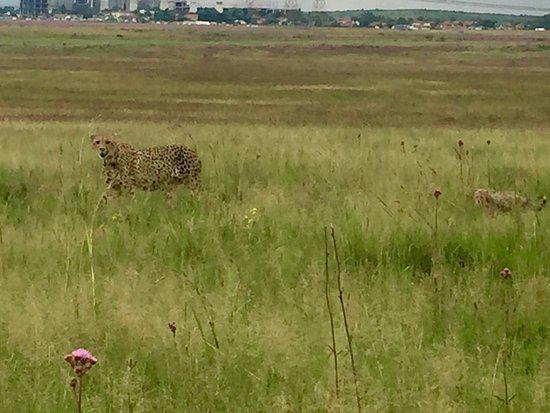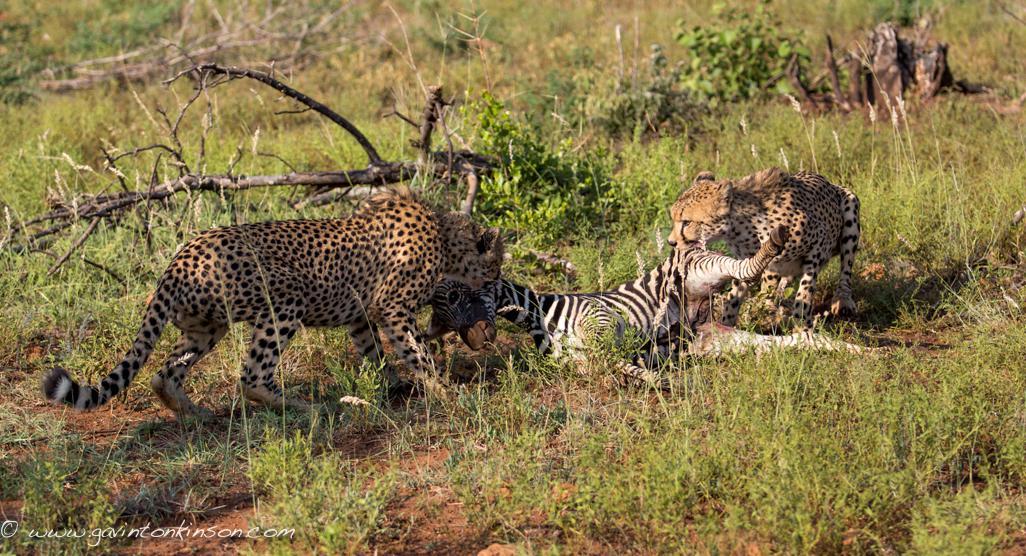The first image is the image on the left, the second image is the image on the right. Analyze the images presented: Is the assertion "The right image contains a single cheetah." valid? Answer yes or no. No. The first image is the image on the left, the second image is the image on the right. Assess this claim about the two images: "The left and right image contains the same number of cheetahs.". Correct or not? Answer yes or no. No. 